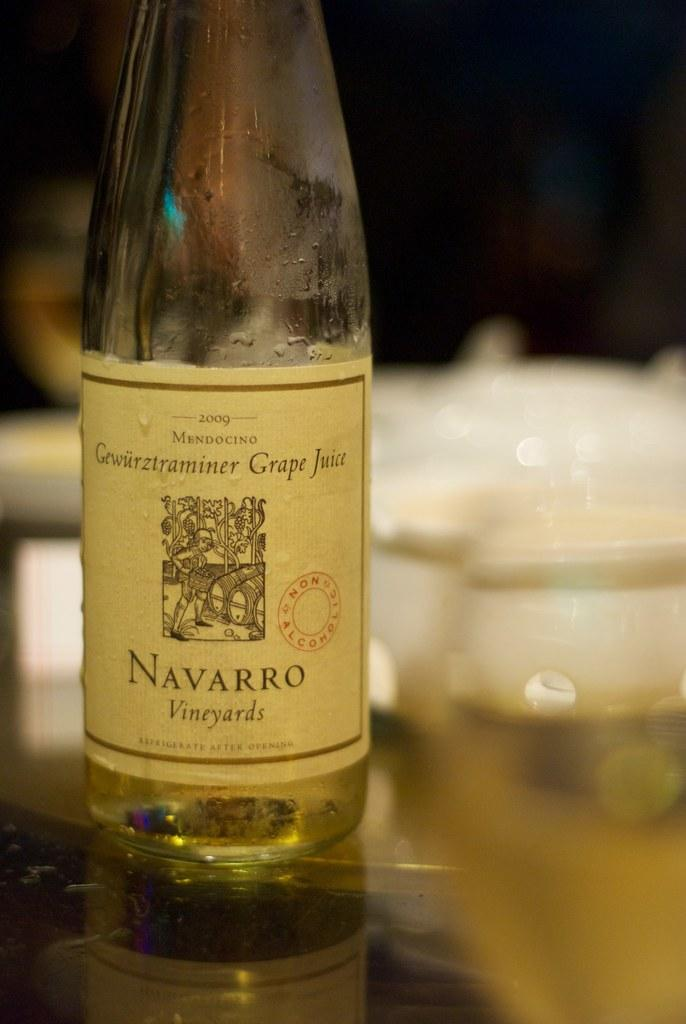<image>
Create a compact narrative representing the image presented. A bottle of wine from Navarro Vineyards is nearly empty. 